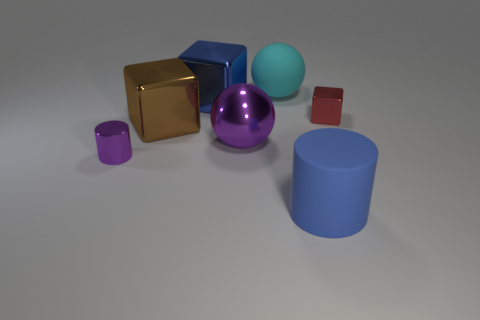Subtract all big cubes. How many cubes are left? 1 Add 3 blue things. How many objects exist? 10 Subtract all spheres. How many objects are left? 5 Subtract 1 cylinders. How many cylinders are left? 1 Subtract 0 yellow spheres. How many objects are left? 7 Subtract all red cylinders. Subtract all gray blocks. How many cylinders are left? 2 Subtract all purple metallic objects. Subtract all cyan balls. How many objects are left? 4 Add 3 big cylinders. How many big cylinders are left? 4 Add 2 green shiny blocks. How many green shiny blocks exist? 2 